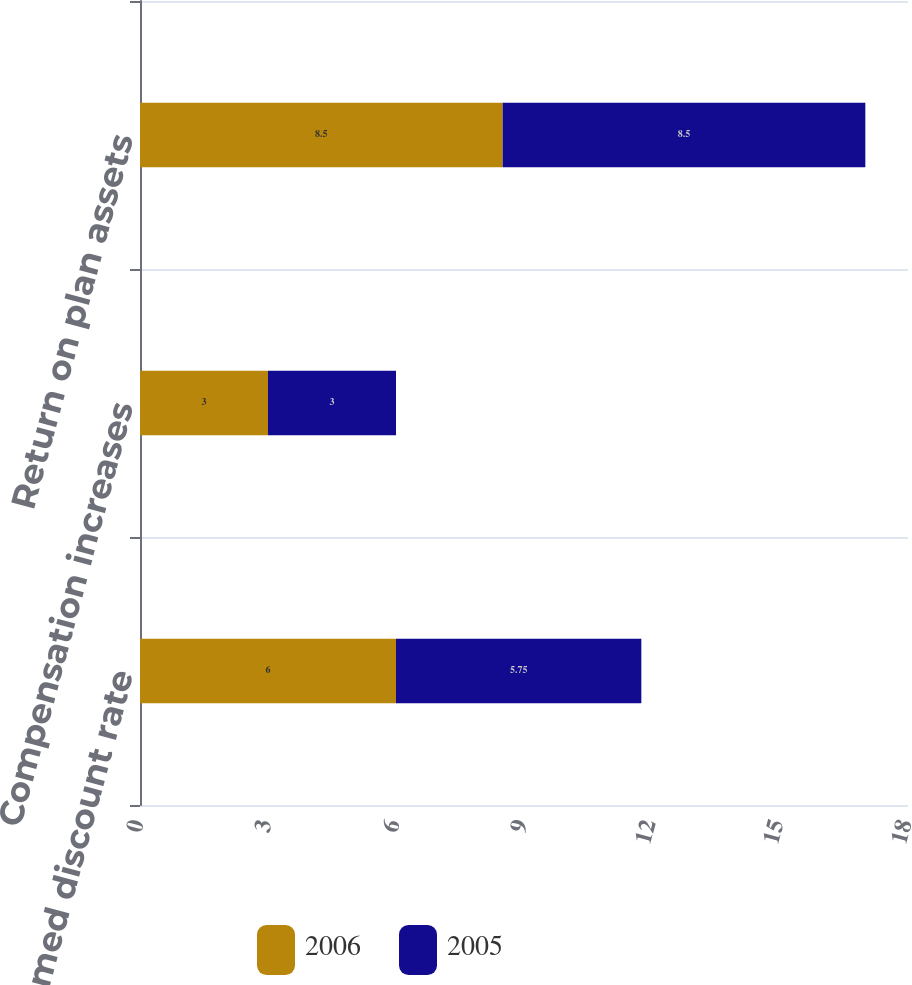Convert chart. <chart><loc_0><loc_0><loc_500><loc_500><stacked_bar_chart><ecel><fcel>Assumed discount rate<fcel>Compensation increases<fcel>Return on plan assets<nl><fcel>2006<fcel>6<fcel>3<fcel>8.5<nl><fcel>2005<fcel>5.75<fcel>3<fcel>8.5<nl></chart> 